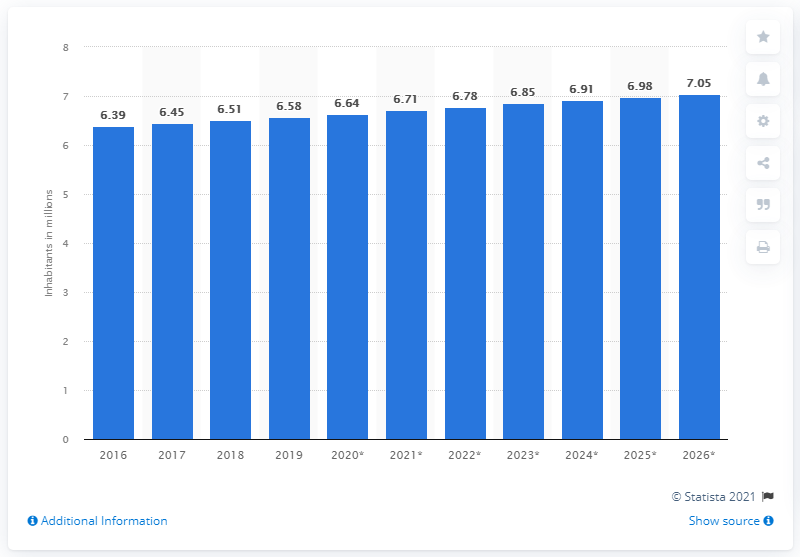Indicate a few pertinent items in this graphic. In 2019, the population of Libya was 6.64 million. 